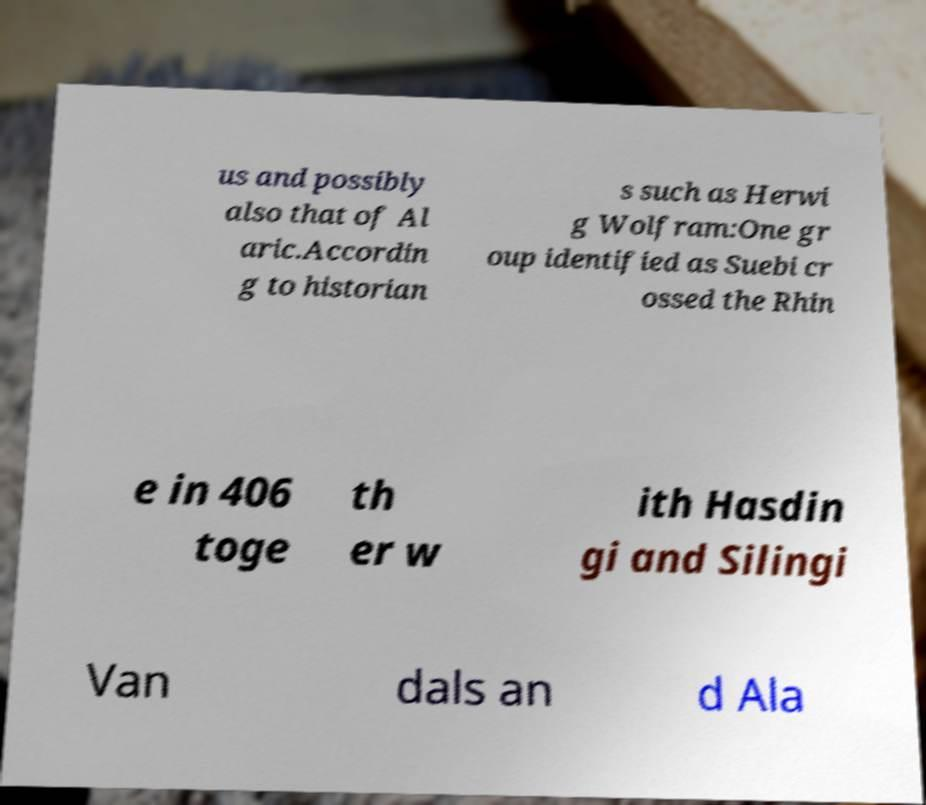Please read and relay the text visible in this image. What does it say? us and possibly also that of Al aric.Accordin g to historian s such as Herwi g Wolfram:One gr oup identified as Suebi cr ossed the Rhin e in 406 toge th er w ith Hasdin gi and Silingi Van dals an d Ala 